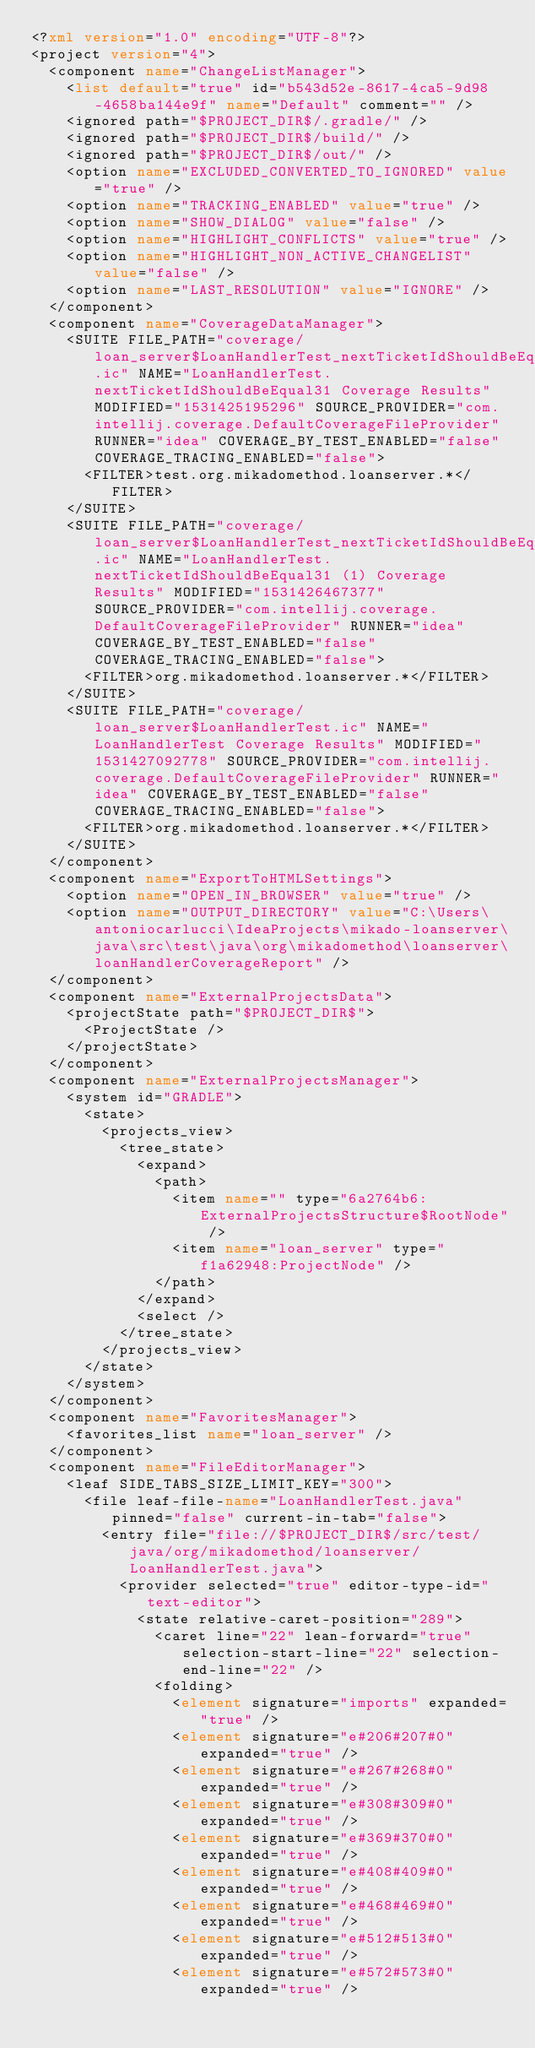<code> <loc_0><loc_0><loc_500><loc_500><_XML_><?xml version="1.0" encoding="UTF-8"?>
<project version="4">
  <component name="ChangeListManager">
    <list default="true" id="b543d52e-8617-4ca5-9d98-4658ba144e9f" name="Default" comment="" />
    <ignored path="$PROJECT_DIR$/.gradle/" />
    <ignored path="$PROJECT_DIR$/build/" />
    <ignored path="$PROJECT_DIR$/out/" />
    <option name="EXCLUDED_CONVERTED_TO_IGNORED" value="true" />
    <option name="TRACKING_ENABLED" value="true" />
    <option name="SHOW_DIALOG" value="false" />
    <option name="HIGHLIGHT_CONFLICTS" value="true" />
    <option name="HIGHLIGHT_NON_ACTIVE_CHANGELIST" value="false" />
    <option name="LAST_RESOLUTION" value="IGNORE" />
  </component>
  <component name="CoverageDataManager">
    <SUITE FILE_PATH="coverage/loan_server$LoanHandlerTest_nextTicketIdShouldBeEqual31.ic" NAME="LoanHandlerTest.nextTicketIdShouldBeEqual31 Coverage Results" MODIFIED="1531425195296" SOURCE_PROVIDER="com.intellij.coverage.DefaultCoverageFileProvider" RUNNER="idea" COVERAGE_BY_TEST_ENABLED="false" COVERAGE_TRACING_ENABLED="false">
      <FILTER>test.org.mikadomethod.loanserver.*</FILTER>
    </SUITE>
    <SUITE FILE_PATH="coverage/loan_server$LoanHandlerTest_nextTicketIdShouldBeEqual31__1_.ic" NAME="LoanHandlerTest.nextTicketIdShouldBeEqual31 (1) Coverage Results" MODIFIED="1531426467377" SOURCE_PROVIDER="com.intellij.coverage.DefaultCoverageFileProvider" RUNNER="idea" COVERAGE_BY_TEST_ENABLED="false" COVERAGE_TRACING_ENABLED="false">
      <FILTER>org.mikadomethod.loanserver.*</FILTER>
    </SUITE>
    <SUITE FILE_PATH="coverage/loan_server$LoanHandlerTest.ic" NAME="LoanHandlerTest Coverage Results" MODIFIED="1531427092778" SOURCE_PROVIDER="com.intellij.coverage.DefaultCoverageFileProvider" RUNNER="idea" COVERAGE_BY_TEST_ENABLED="false" COVERAGE_TRACING_ENABLED="false">
      <FILTER>org.mikadomethod.loanserver.*</FILTER>
    </SUITE>
  </component>
  <component name="ExportToHTMLSettings">
    <option name="OPEN_IN_BROWSER" value="true" />
    <option name="OUTPUT_DIRECTORY" value="C:\Users\antoniocarlucci\IdeaProjects\mikado-loanserver\java\src\test\java\org\mikadomethod\loanserver\loanHandlerCoverageReport" />
  </component>
  <component name="ExternalProjectsData">
    <projectState path="$PROJECT_DIR$">
      <ProjectState />
    </projectState>
  </component>
  <component name="ExternalProjectsManager">
    <system id="GRADLE">
      <state>
        <projects_view>
          <tree_state>
            <expand>
              <path>
                <item name="" type="6a2764b6:ExternalProjectsStructure$RootNode" />
                <item name="loan_server" type="f1a62948:ProjectNode" />
              </path>
            </expand>
            <select />
          </tree_state>
        </projects_view>
      </state>
    </system>
  </component>
  <component name="FavoritesManager">
    <favorites_list name="loan_server" />
  </component>
  <component name="FileEditorManager">
    <leaf SIDE_TABS_SIZE_LIMIT_KEY="300">
      <file leaf-file-name="LoanHandlerTest.java" pinned="false" current-in-tab="false">
        <entry file="file://$PROJECT_DIR$/src/test/java/org/mikadomethod/loanserver/LoanHandlerTest.java">
          <provider selected="true" editor-type-id="text-editor">
            <state relative-caret-position="289">
              <caret line="22" lean-forward="true" selection-start-line="22" selection-end-line="22" />
              <folding>
                <element signature="imports" expanded="true" />
                <element signature="e#206#207#0" expanded="true" />
                <element signature="e#267#268#0" expanded="true" />
                <element signature="e#308#309#0" expanded="true" />
                <element signature="e#369#370#0" expanded="true" />
                <element signature="e#408#409#0" expanded="true" />
                <element signature="e#468#469#0" expanded="true" />
                <element signature="e#512#513#0" expanded="true" />
                <element signature="e#572#573#0" expanded="true" /></code> 